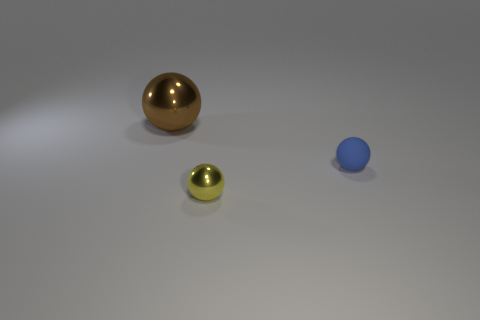Subtract all shiny spheres. How many spheres are left? 1 Add 3 blue objects. How many objects exist? 6 Add 1 red metal spheres. How many red metal spheres exist? 1 Subtract all blue spheres. How many spheres are left? 2 Subtract 0 yellow cylinders. How many objects are left? 3 Subtract 1 balls. How many balls are left? 2 Subtract all red spheres. Subtract all blue cylinders. How many spheres are left? 3 Subtract all gray cylinders. How many blue balls are left? 1 Subtract all small blue things. Subtract all blue rubber spheres. How many objects are left? 1 Add 3 brown spheres. How many brown spheres are left? 4 